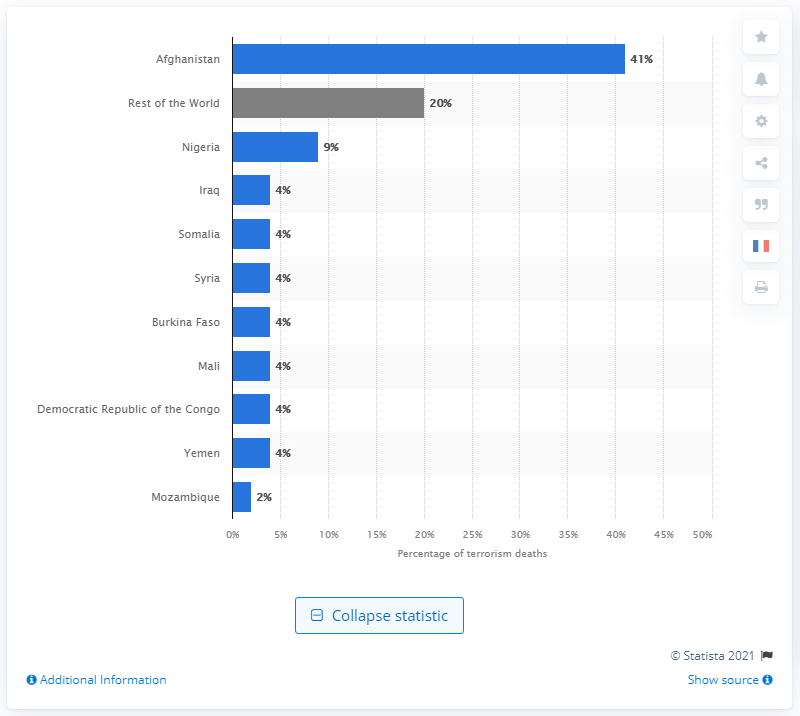List a handful of essential elements in this visual. Afghanistan had the highest number of deaths from terrorism in 2019, according to recent data. Nigeria has the second highest number of deaths as a result of terrorism, after the United States. 